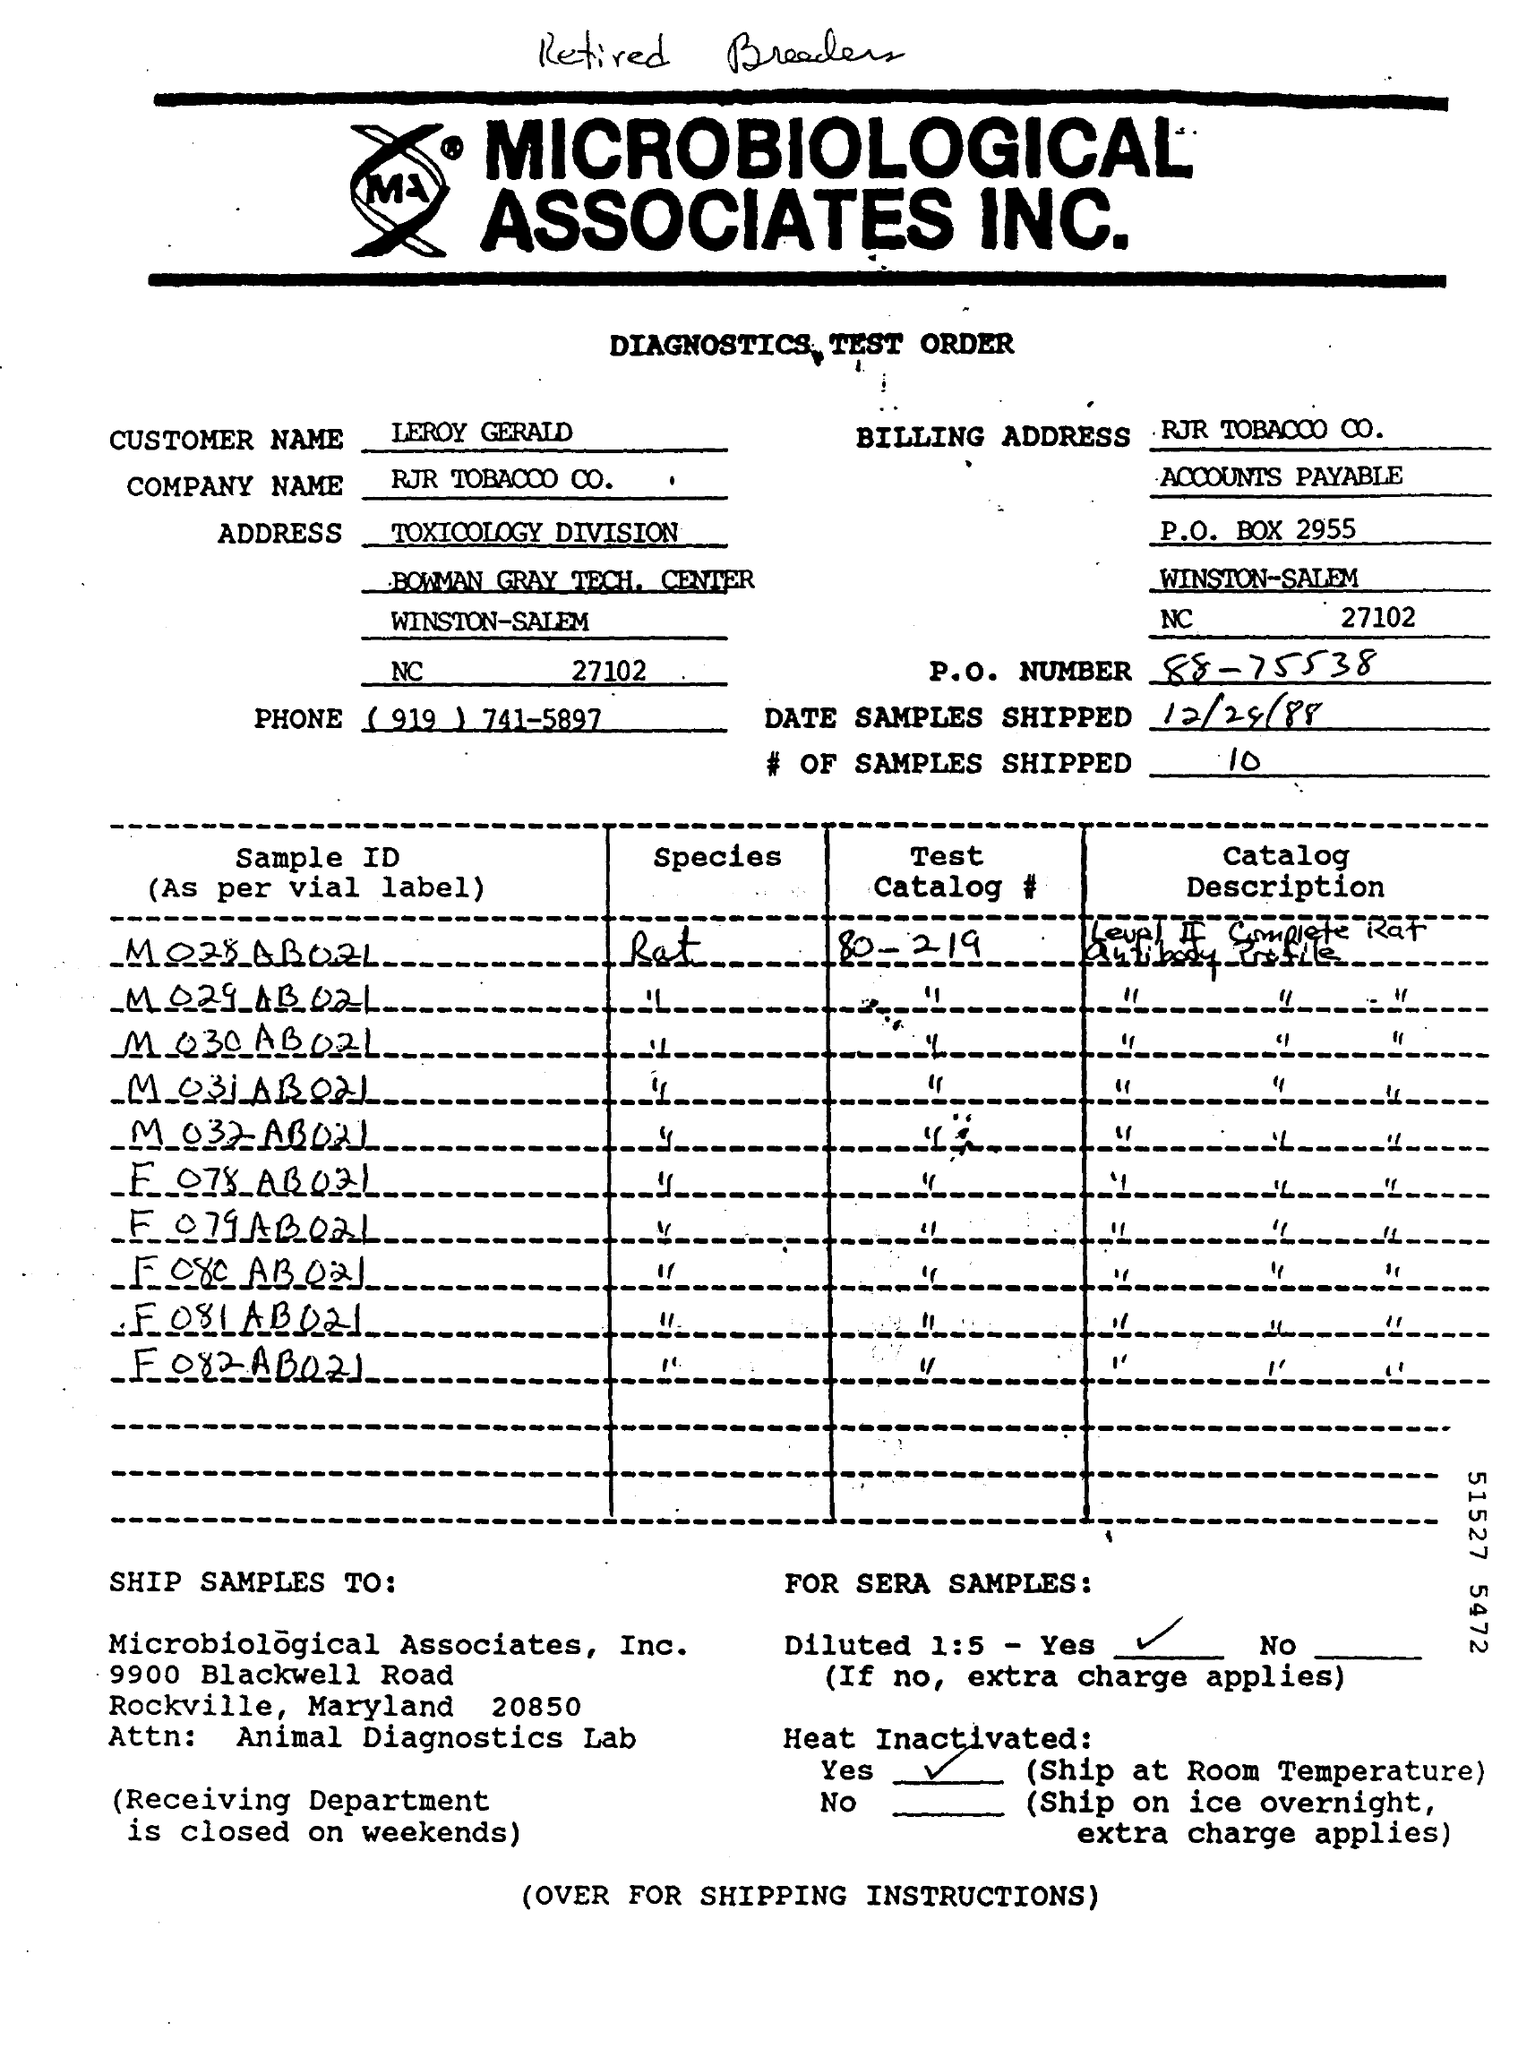Specify some key components in this picture. The P.O. Number is 88-75538. The customer's name is Leroy Gerald. The number of samples shipped was 10. The phone number is (919) 741-5897. The company name is RJR Tobacco Company. 